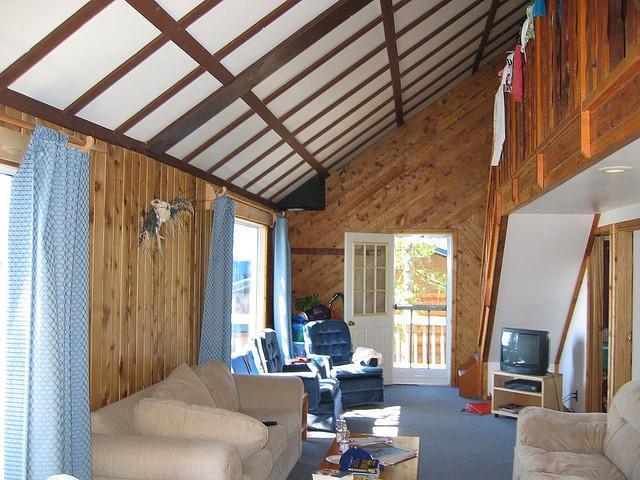How many couches are there?
Give a very brief answer. 2. 